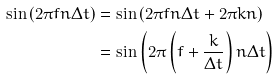Convert formula to latex. <formula><loc_0><loc_0><loc_500><loc_500>\sin \left ( 2 \pi f n \Delta t \right ) & = \sin \left ( 2 \pi f n \Delta t + 2 \pi k n \right ) \\ & = \sin \left ( 2 \pi \left ( f + \frac { k } { \Delta t } \right ) n \Delta t \right )</formula> 